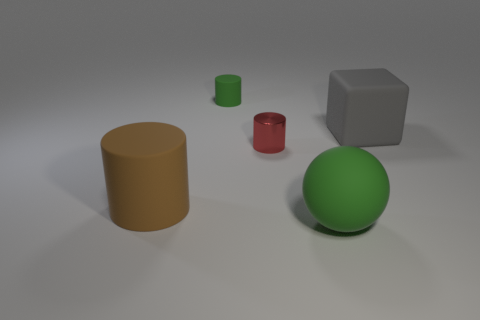Subtract all small green matte cylinders. How many cylinders are left? 2 Subtract 1 cylinders. How many cylinders are left? 2 Add 4 small gray cylinders. How many objects exist? 9 Subtract all purple cylinders. Subtract all purple cubes. How many cylinders are left? 3 Subtract all cylinders. How many objects are left? 2 Add 1 large gray shiny cylinders. How many large gray shiny cylinders exist? 1 Subtract 0 red balls. How many objects are left? 5 Subtract all small yellow cylinders. Subtract all brown rubber things. How many objects are left? 4 Add 5 green matte cylinders. How many green matte cylinders are left? 6 